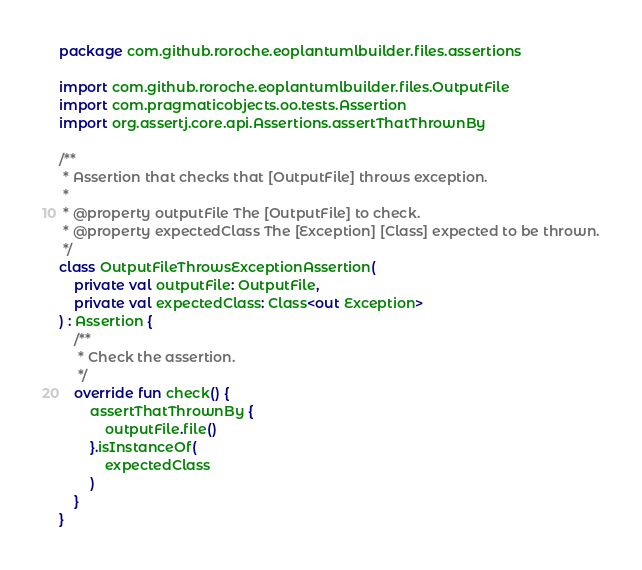Convert code to text. <code><loc_0><loc_0><loc_500><loc_500><_Kotlin_>package com.github.roroche.eoplantumlbuilder.files.assertions

import com.github.roroche.eoplantumlbuilder.files.OutputFile
import com.pragmaticobjects.oo.tests.Assertion
import org.assertj.core.api.Assertions.assertThatThrownBy

/**
 * Assertion that checks that [OutputFile] throws exception.
 *
 * @property outputFile The [OutputFile] to check.
 * @property expectedClass The [Exception] [Class] expected to be thrown.
 */
class OutputFileThrowsExceptionAssertion(
    private val outputFile: OutputFile,
    private val expectedClass: Class<out Exception>
) : Assertion {
    /**
     * Check the assertion.
     */
    override fun check() {
        assertThatThrownBy {
            outputFile.file()
        }.isInstanceOf(
            expectedClass
        )
    }
}</code> 